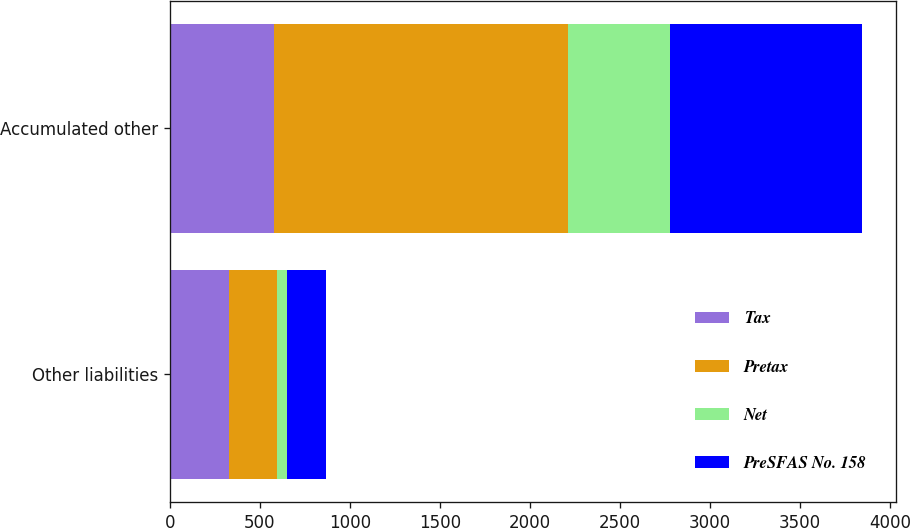<chart> <loc_0><loc_0><loc_500><loc_500><stacked_bar_chart><ecel><fcel>Other liabilities<fcel>Accumulated other<nl><fcel>Tax<fcel>327<fcel>581<nl><fcel>Pretax<fcel>269<fcel>1631<nl><fcel>Net<fcel>52<fcel>567<nl><fcel>PreSFAS No. 158<fcel>217<fcel>1064<nl></chart> 